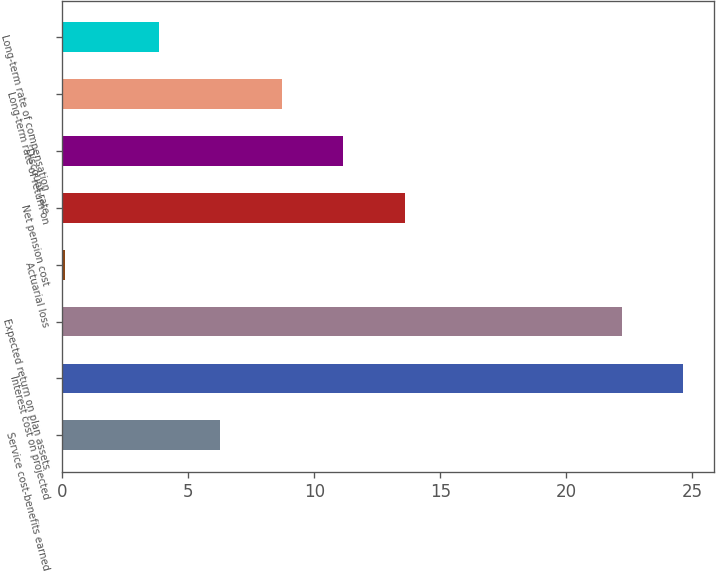Convert chart to OTSL. <chart><loc_0><loc_0><loc_500><loc_500><bar_chart><fcel>Service cost-benefits earned<fcel>Interest cost on projected<fcel>Expected return on plan assets<fcel>Actuarial loss<fcel>Net pension cost<fcel>Discount rate<fcel>Long-term rate of return on<fcel>Long-term rate of compensation<nl><fcel>6.27<fcel>24.64<fcel>22.2<fcel>0.1<fcel>13.59<fcel>11.15<fcel>8.71<fcel>3.83<nl></chart> 